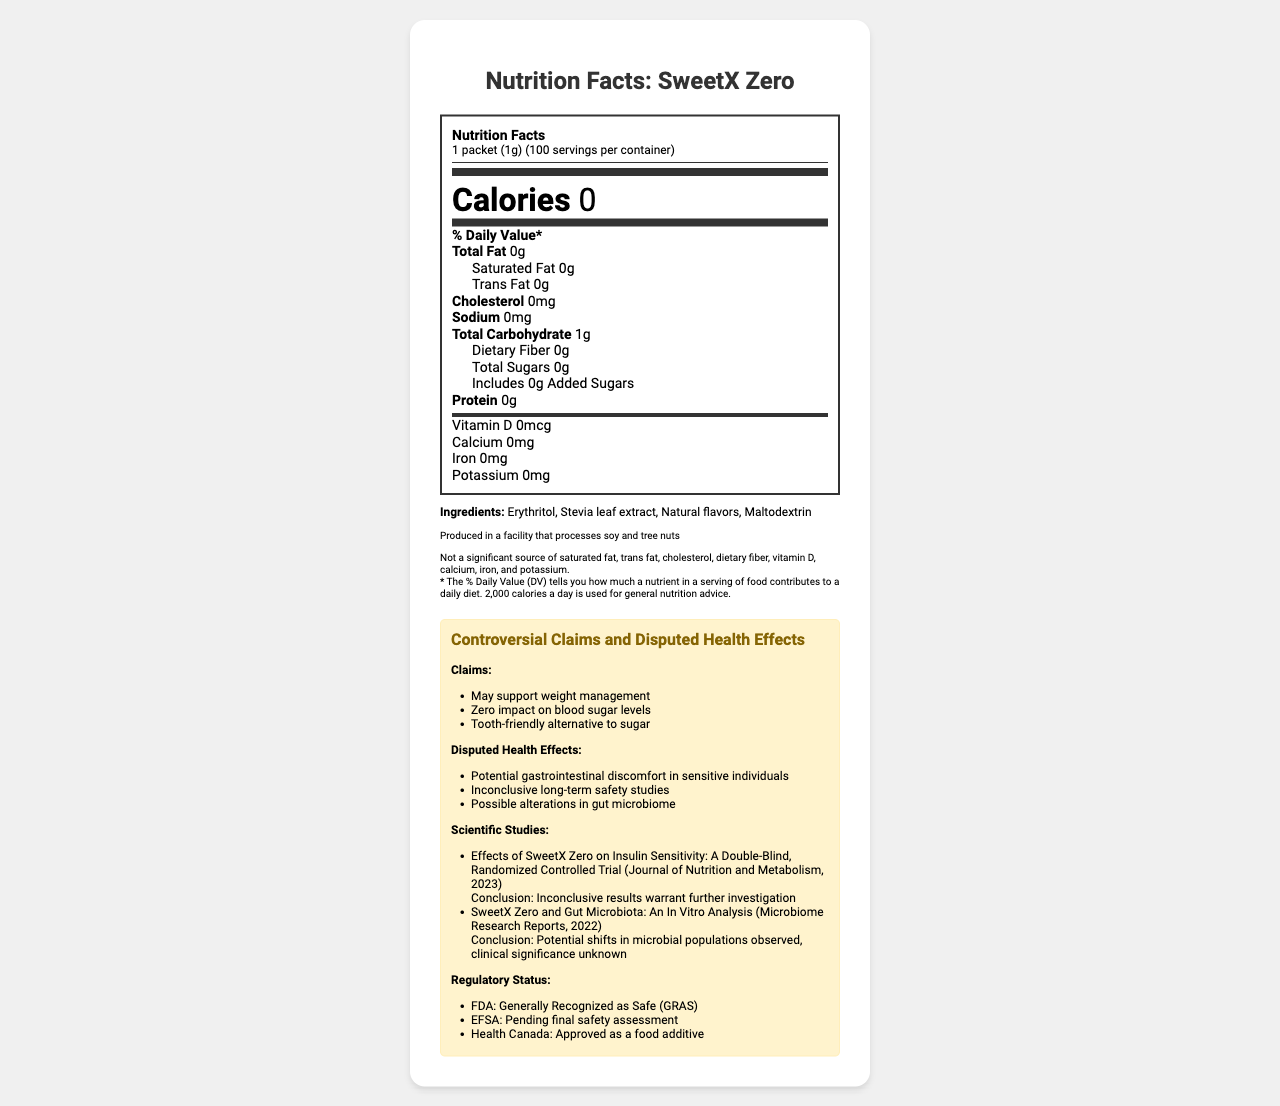what is the serving size of SweetX Zero? The serving size is explicitly stated in the document under the "serving size" heading.
Answer: 1 packet (1g) how many calories are there per serving? According to the Nutrition Facts, the calories per serving are listed as 0.
Answer: 0 name one of the ingredients in SweetX Zero The ingredient list includes Erythritol, Stevia leaf extract, Natural flavors, and Maltodextrin.
Answer: Erythritol how many scientific studies are cited in the document? The document lists two scientific studies under the section "Scientific Studies."
Answer: 2 What claims does SweetX Zero make regarding health benefits? These claims are listed under the "Controversial Claims" section of the document.
Answer: May support weight management, Zero impact on blood sugar levels, Tooth-friendly alternative to sugar what is the potential health effect of SweetX Zero on the gut microbiome? This is listed under the "Disputed Health Effects" section.
Answer: Possible alterations in gut microbiome which regulatory agency has approved SweetX Zero as a food additive? A. FDA B. EFSA C. Health Canada Health Canada has approved it as a food additive according to the "Regulatory Status" section.
Answer: C what is the cholesterol content per serving of SweetX Zero? A. 0mg B. 10mg C. 20mg The document states that the cholesterol content is 0mg per serving.
Answer: A Is SweetX Zero recognized as safe by the FDA? The document states that the FDA considers SweetX Zero as Generally Recognized as Safe (GRAS).
Answer: Yes summarize the main idea of the document. The document includes detailed information about SweetX Zero, specifying its nutritional contents, ingredients, health claims, disputed health effects, scientific studies, and regulatory status.
Answer: The document provides the nutrition facts, ingredient list, and regulatory status of SweetX Zero, a sweetener with controversial claims regarding health benefits and disputed health effects. It also includes information on scientific studies and potential health issues. how much dietary fiber is in a serving of SweetX Zero? The Nutrition Facts label specifies that the dietary fiber content is 0g per serving.
Answer: 0g what is the conclusion of the study titled "SweetX Zero and Gut Microbiota: An In Vitro Analysis"? This conclusion is provided under the "Scientific Studies" section for the respective study.
Answer: Potential shifts in microbial populations observed, clinical significance unknown how many servings are there in a container of SweetX Zero? The document lists "servings per container" as 100.
Answer: 100 does SweetX Zero have any added sugars? According to the Nutrition Facts label, SweetX Zero contains 0g of added sugars.
Answer: No can the impact of SweetX Zero on insulin sensitivity be conclusively determined from the available studies? The document states that the results of the study titled "Effects of SweetX Zero on Insulin Sensitivity: A Double-Blind, Randomized Controlled Trial" were inconclusive, thus warranting further investigation.
Answer: No what is the year of publication for the study on the effects of SweetX Zero on insulin sensitivity? The document mentions that this study was published in the year 2023.
Answer: 2023 Based on the document, what are the main sources of the potential gastrointestinal discomfort from SweetX Zero? This is explicitly listed under the "Disputed Health Effects" section.
Answer: Potential gastrointestinal discomfort in sensitive individuals how is SweetX Zero described in terms of vitamin D content? The document specifies that the vitamin D content is 0mcg.
Answer: 0mcg is SweetX Zero produced in a facility that processes soy and tree nuts? The allergen warning in the document states that it is produced in a facility that processes soy and tree nuts.
Answer: Yes what is the scientific journal title related to the study of SweetX Zero on gut microbiota? This is the journal mentioned under the "Scientific Studies" section for the study on gut microbiota.
Answer: Microbiome Research Reports what are the natural flavors used in SweetX Zero? The document lists "Natural flavors" as an ingredient, but it does not specify what those natural flavors are comprised of.
Answer: Cannot be determined 